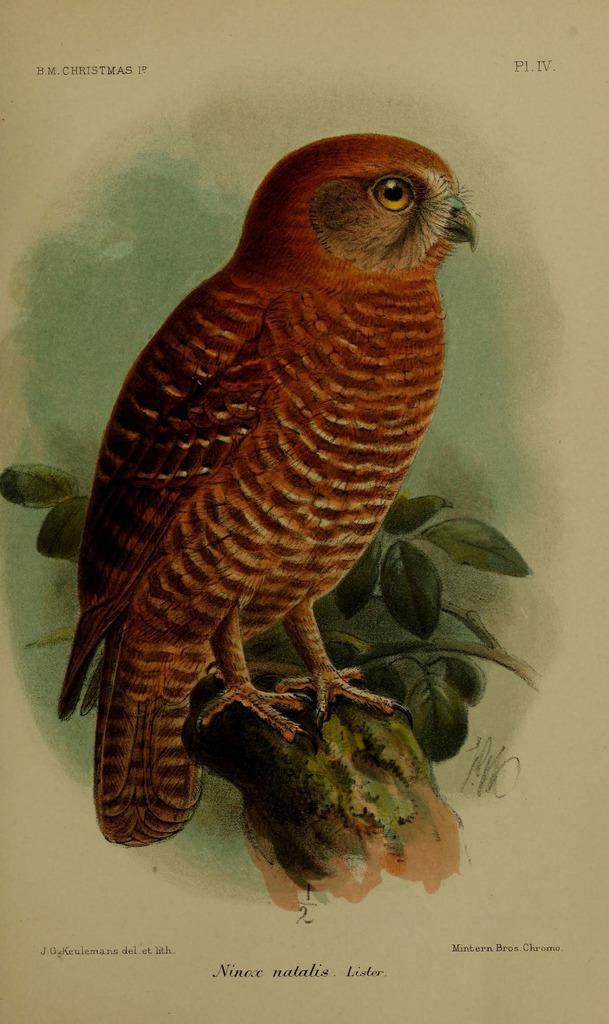What is the main subject of the image? The main subject of the image is bird art. Is there any text associated with the image? Yes, there is text at the bottom of the image. What type of war is depicted in the bird art? There is no war depicted in the bird art; the image features bird art without any reference to war. 